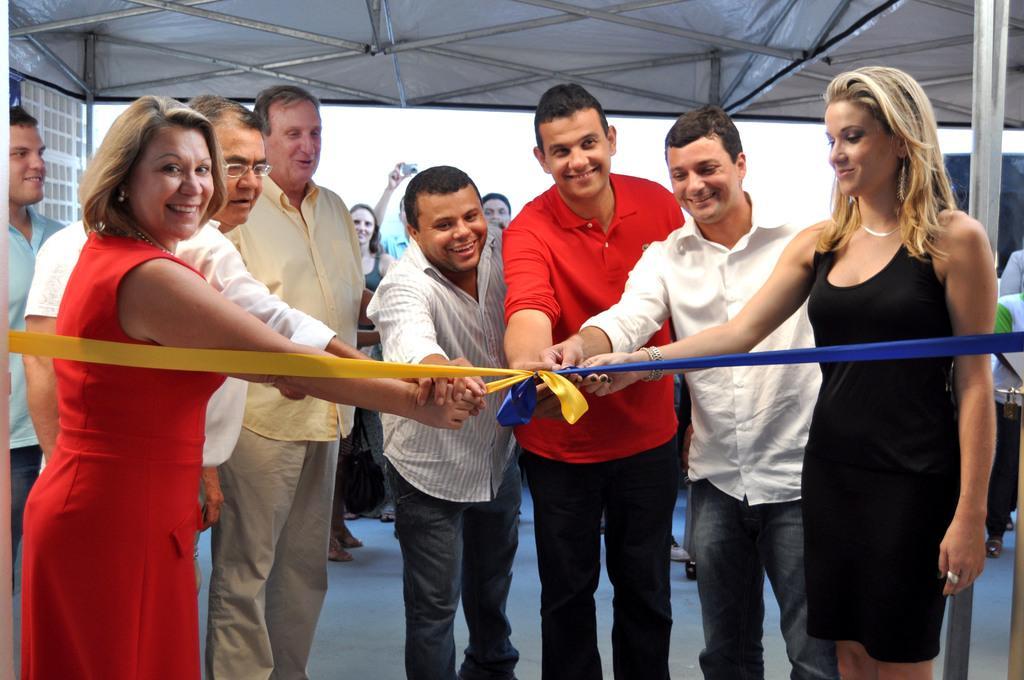Can you describe this image briefly? In this image we can see few persons are standing and holding a ribbon with their hands all together. In the background there are few persons, poles, wall and a person is holding a camera in his hand and they are all under a tent. 